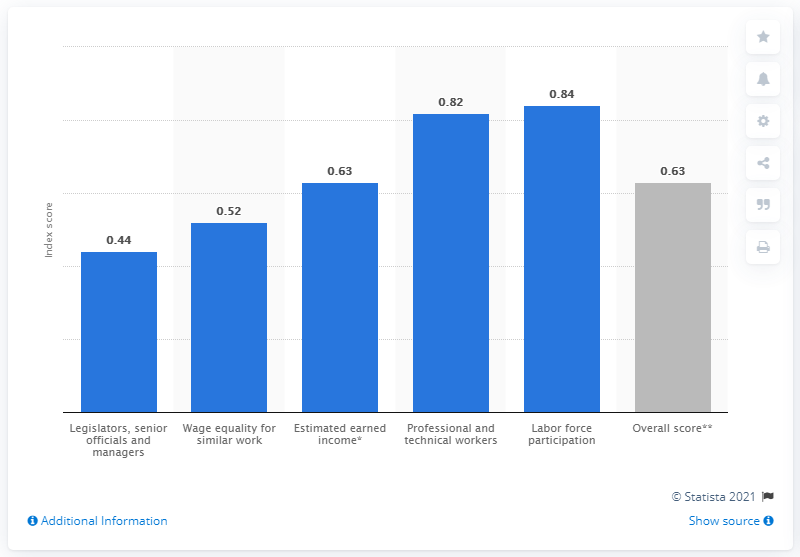What was Peru's gender gap index score in 2021? In 2021, Peru's gender gap index score for labor force participation was 0.63. This metric measures the gap between men and women in terms of their rate of participation in the labor force. 